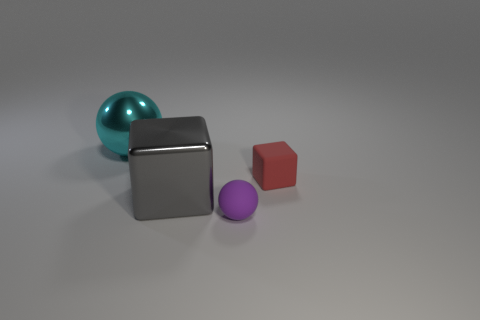Is there another purple matte ball of the same size as the rubber sphere?
Offer a terse response. No. Is the shape of the small matte thing behind the small purple rubber object the same as  the large gray object?
Give a very brief answer. Yes. The rubber block is what color?
Your response must be concise. Red. Is there a tiny red rubber block?
Your response must be concise. Yes. Is the number of big purple things the same as the number of big objects?
Provide a short and direct response. No. The ball that is the same material as the large gray object is what size?
Keep it short and to the point. Large. What is the shape of the large metallic object right of the big metallic object to the left of the metallic object in front of the large cyan shiny sphere?
Make the answer very short. Cube. Are there an equal number of big cubes that are behind the big gray shiny thing and large purple cubes?
Provide a succinct answer. Yes. Is the small purple object the same shape as the red matte thing?
Offer a terse response. No. What number of things are either big metal objects that are right of the cyan shiny sphere or large metallic spheres?
Offer a terse response. 2. 